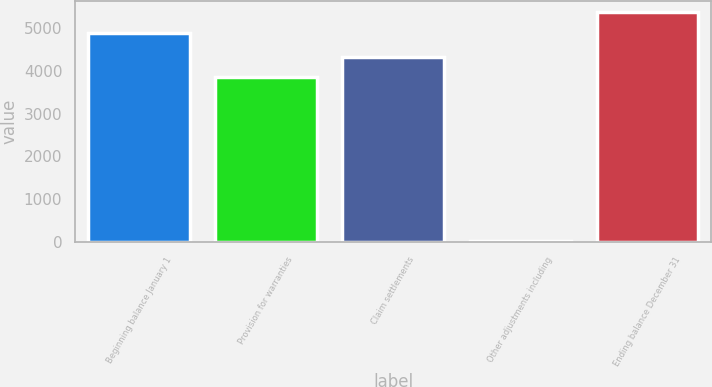<chart> <loc_0><loc_0><loc_500><loc_500><bar_chart><fcel>Beginning balance January 1<fcel>Provision for warranties<fcel>Claim settlements<fcel>Other adjustments including<fcel>Ending balance December 31<nl><fcel>4875<fcel>3845<fcel>4330.5<fcel>33<fcel>5360.5<nl></chart> 